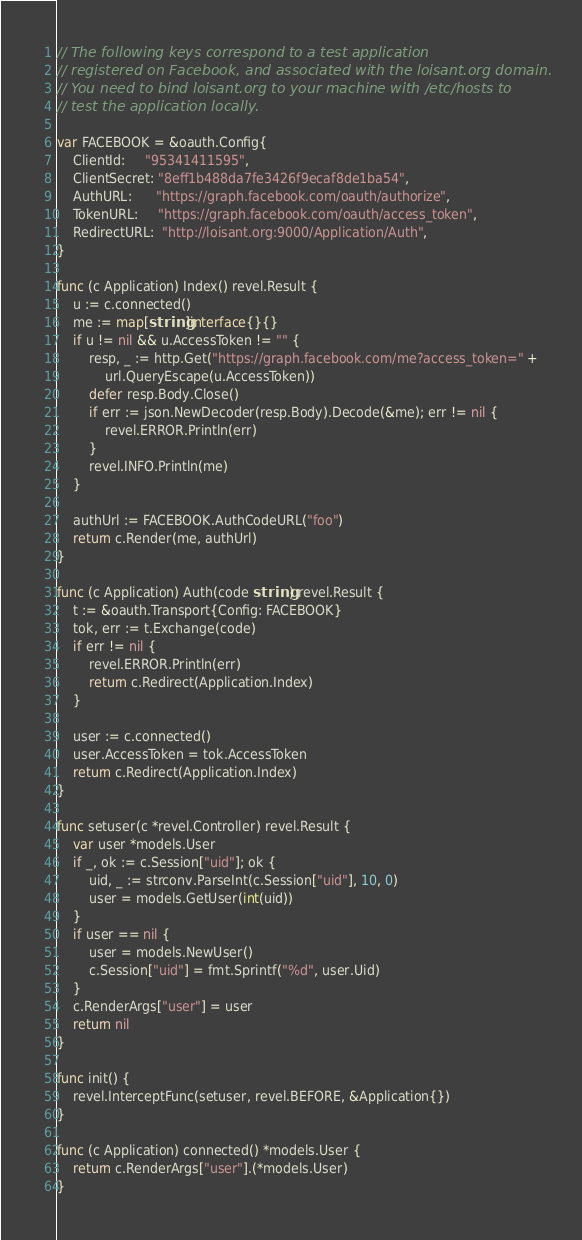Convert code to text. <code><loc_0><loc_0><loc_500><loc_500><_Go_>
// The following keys correspond to a test application
// registered on Facebook, and associated with the loisant.org domain.
// You need to bind loisant.org to your machine with /etc/hosts to
// test the application locally.

var FACEBOOK = &oauth.Config{
	ClientId:     "95341411595",
	ClientSecret: "8eff1b488da7fe3426f9ecaf8de1ba54",
	AuthURL:      "https://graph.facebook.com/oauth/authorize",
	TokenURL:     "https://graph.facebook.com/oauth/access_token",
	RedirectURL:  "http://loisant.org:9000/Application/Auth",
}

func (c Application) Index() revel.Result {
	u := c.connected()
	me := map[string]interface{}{}
	if u != nil && u.AccessToken != "" {
		resp, _ := http.Get("https://graph.facebook.com/me?access_token=" +
			url.QueryEscape(u.AccessToken))
		defer resp.Body.Close()
		if err := json.NewDecoder(resp.Body).Decode(&me); err != nil {
			revel.ERROR.Println(err)
		}
		revel.INFO.Println(me)
	}

	authUrl := FACEBOOK.AuthCodeURL("foo")
	return c.Render(me, authUrl)
}

func (c Application) Auth(code string) revel.Result {
	t := &oauth.Transport{Config: FACEBOOK}
	tok, err := t.Exchange(code)
	if err != nil {
		revel.ERROR.Println(err)
		return c.Redirect(Application.Index)
	}

	user := c.connected()
	user.AccessToken = tok.AccessToken
	return c.Redirect(Application.Index)
}

func setuser(c *revel.Controller) revel.Result {
	var user *models.User
	if _, ok := c.Session["uid"]; ok {
		uid, _ := strconv.ParseInt(c.Session["uid"], 10, 0)
		user = models.GetUser(int(uid))
	}
	if user == nil {
		user = models.NewUser()
		c.Session["uid"] = fmt.Sprintf("%d", user.Uid)
	}
	c.RenderArgs["user"] = user
	return nil
}

func init() {
	revel.InterceptFunc(setuser, revel.BEFORE, &Application{})
}

func (c Application) connected() *models.User {
	return c.RenderArgs["user"].(*models.User)
}
</code> 